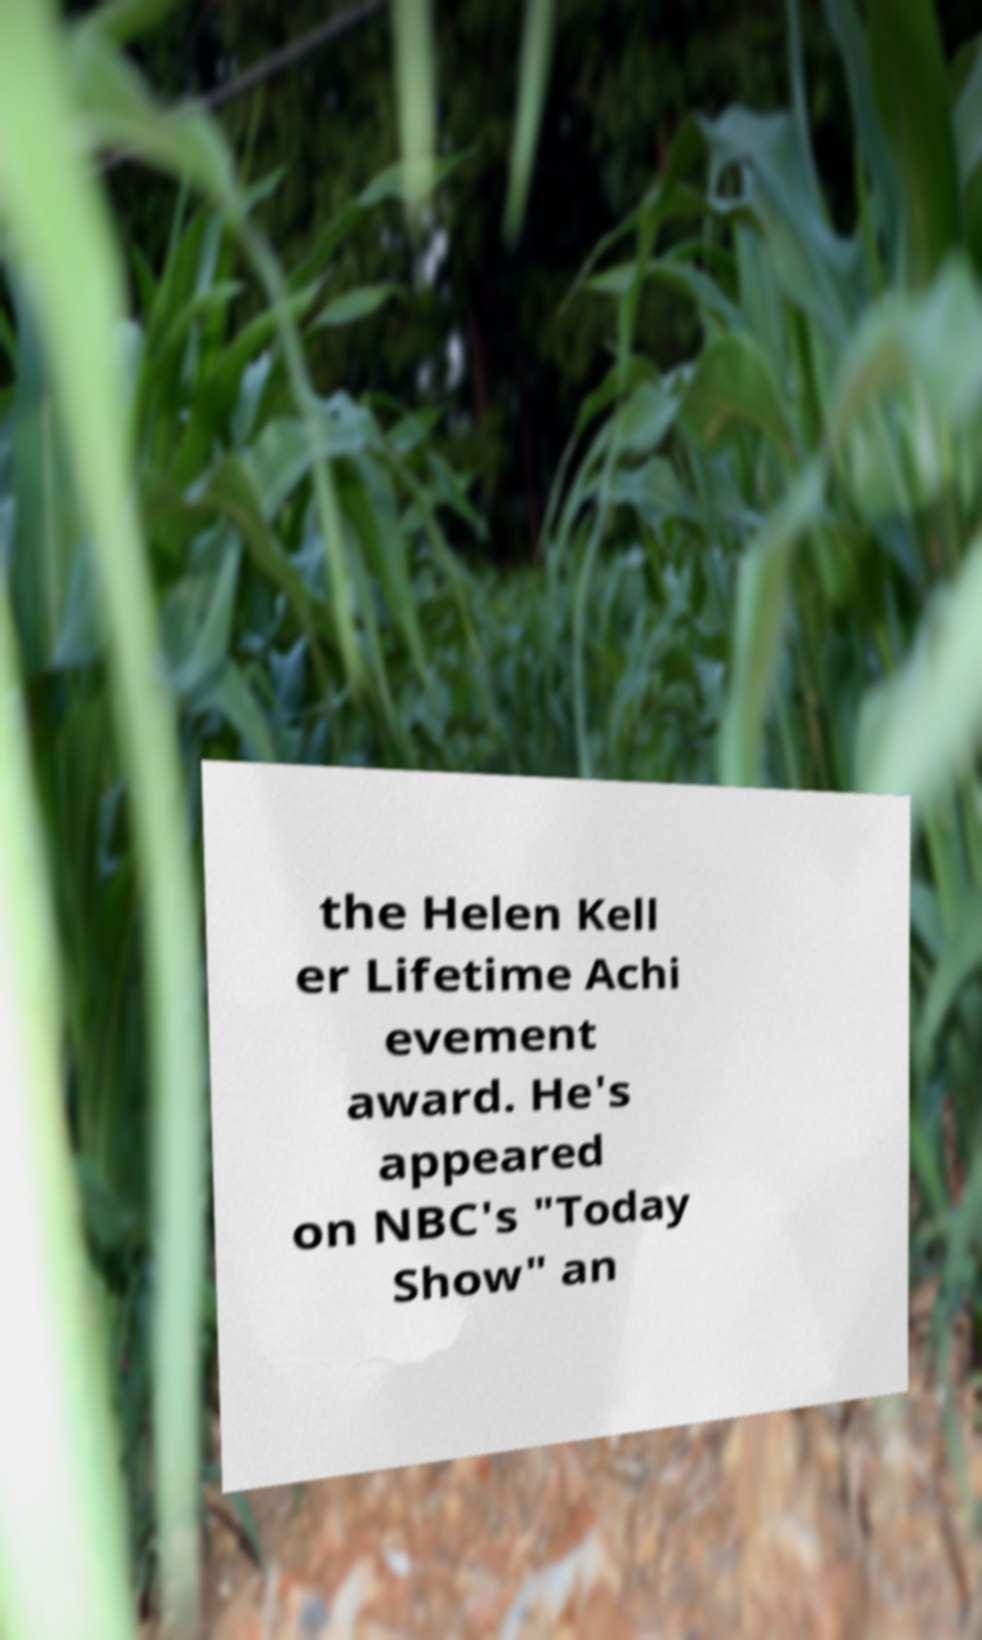What messages or text are displayed in this image? I need them in a readable, typed format. the Helen Kell er Lifetime Achi evement award. He's appeared on NBC's "Today Show" an 